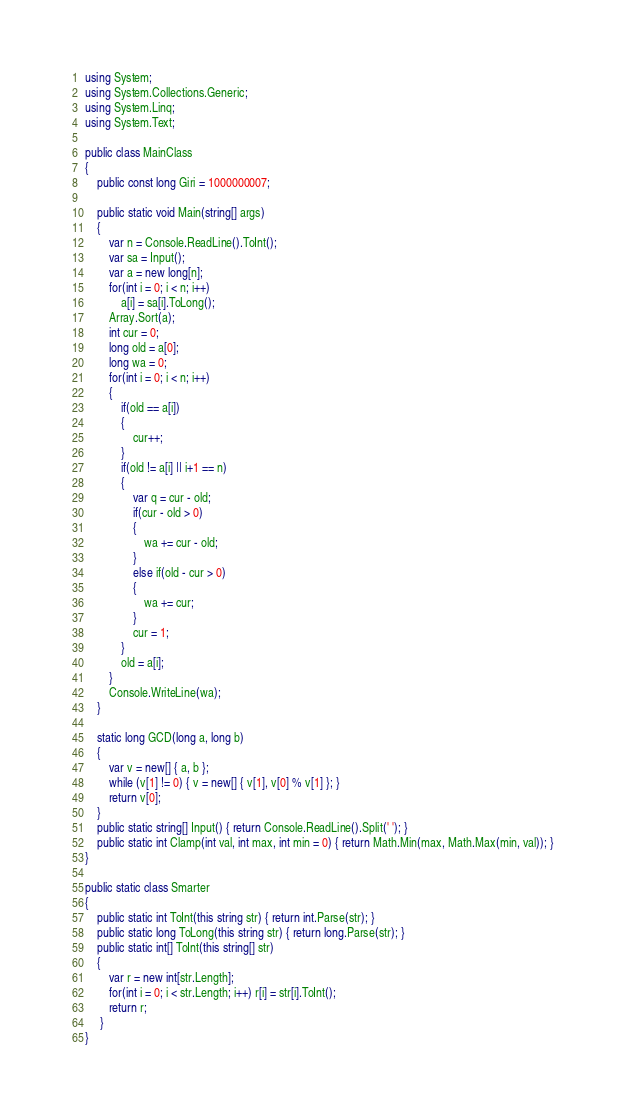Convert code to text. <code><loc_0><loc_0><loc_500><loc_500><_C#_>using System;
using System.Collections.Generic;
using System.Linq;
using System.Text;

public class MainClass
{
	public const long Giri = 1000000007;

	public static void Main(string[] args)
	{
		var n = Console.ReadLine().ToInt();
		var sa = Input();
		var a = new long[n];
		for(int i = 0; i < n; i++)
			a[i] = sa[i].ToLong();
		Array.Sort(a);
		int cur = 0;
		long old = a[0];
		long wa = 0;
		for(int i = 0; i < n; i++)
		{
			if(old == a[i])
			{
				cur++;
			}
			if(old != a[i] || i+1 == n)
			{
				var q = cur - old;
				if(cur - old > 0)
				{
					wa += cur - old;
				}
				else if(old - cur > 0)
				{
					wa += cur;
				}
				cur = 1;
			}
			old = a[i];
		}
		Console.WriteLine(wa);
	}

	static long GCD(long a, long b)
	{
		var v = new[] { a, b };
		while (v[1] != 0) { v = new[] { v[1], v[0] % v[1] }; }
		return v[0];
	}
	public static string[] Input() { return Console.ReadLine().Split(' '); }
	public static int Clamp(int val, int max, int min = 0) { return Math.Min(max, Math.Max(min, val)); }
}

public static class Smarter
{
	public static int ToInt(this string str) { return int.Parse(str); }
	public static long ToLong(this string str) { return long.Parse(str); }
	public static int[] ToInt(this string[] str)
	{
		var r = new int[str.Length];
		for(int i = 0; i < str.Length; i++) r[i] = str[i].ToInt();
		return r;
	 }
}
</code> 